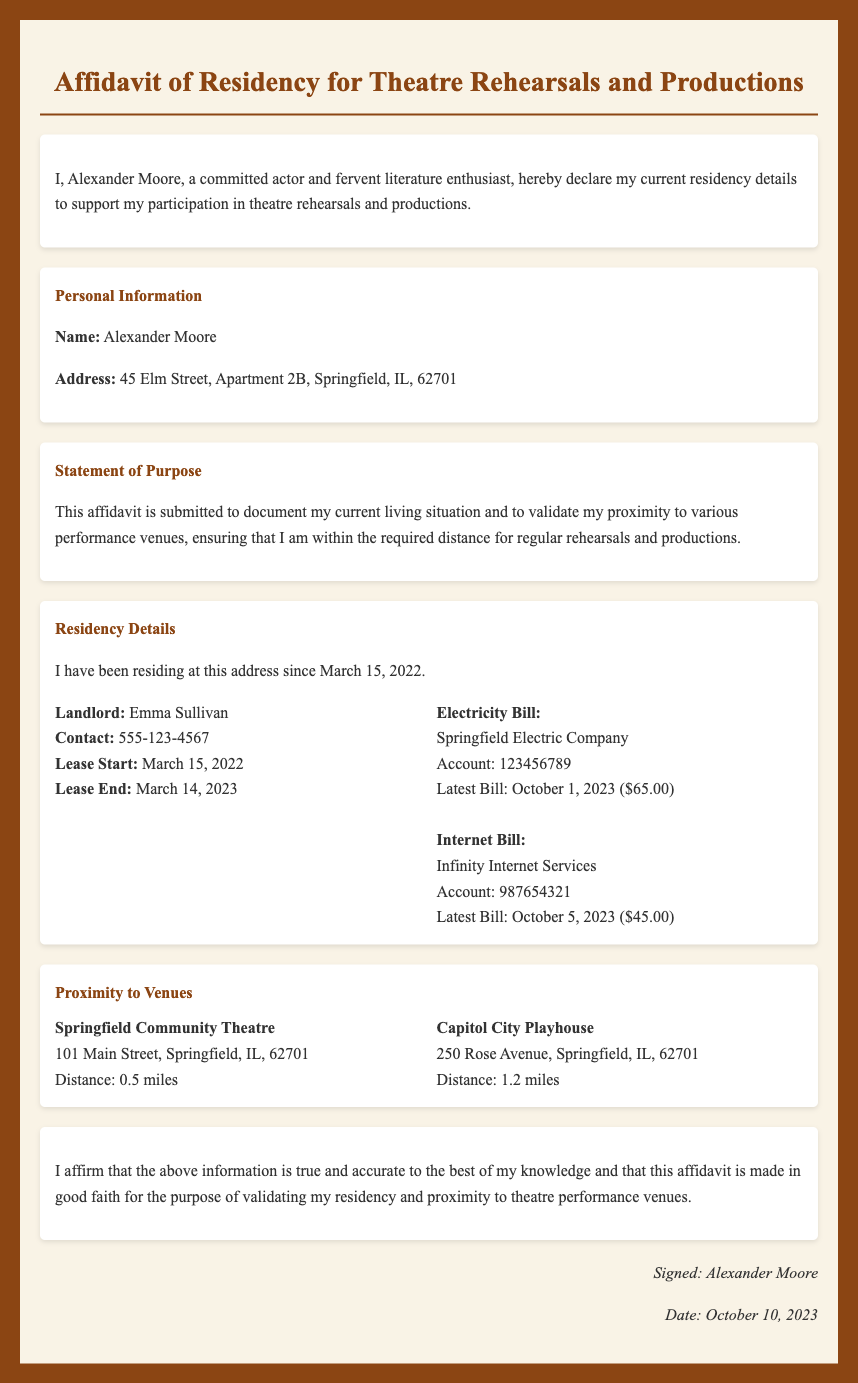What is the name of the affiant? The name of the person making the affidavit is provided in the personal information section.
Answer: Alexander Moore What is the address listed in the affidavit? The address can be found in the personal information section of the document.
Answer: 45 Elm Street, Apartment 2B, Springfield, IL, 62701 When did the affiant start residing at the current address? The date the affiant started residing at the address is stated in the residency details section.
Answer: March 15, 2022 Who is the landlord of the affiant? The landlord's name is mentioned in the residency details section.
Answer: Emma Sullivan What is the distance to Springfield Community Theatre? The distance to this specific venue is listed under the proximity to venues section.
Answer: 0.5 miles What is the amount of the latest electricity bill? The amount is specified in the residency details section under the electricity bill.
Answer: $65.00 What is the lease end date? The lease end date is indicated in the residency details section.
Answer: March 14, 2023 How many miles is Capitol City Playhouse from the affiant’s address? The distance is stated in the proximity to venues section.
Answer: 1.2 miles On what date was this affidavit signed? The date the affidavit was signed is provided in the signature section.
Answer: October 10, 2023 